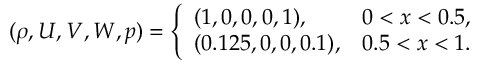Convert formula to latex. <formula><loc_0><loc_0><loc_500><loc_500>( \rho , U , V , W , p ) = \left \{ \begin{array} { l l } { ( 1 , 0 , 0 , 0 , 1 ) , } & { 0 < x < 0 . 5 , } \\ { ( 0 . 1 2 5 , 0 , 0 , 0 . 1 ) , } & { 0 . 5 < x < 1 . } \end{array}</formula> 